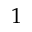<formula> <loc_0><loc_0><loc_500><loc_500>1</formula> 